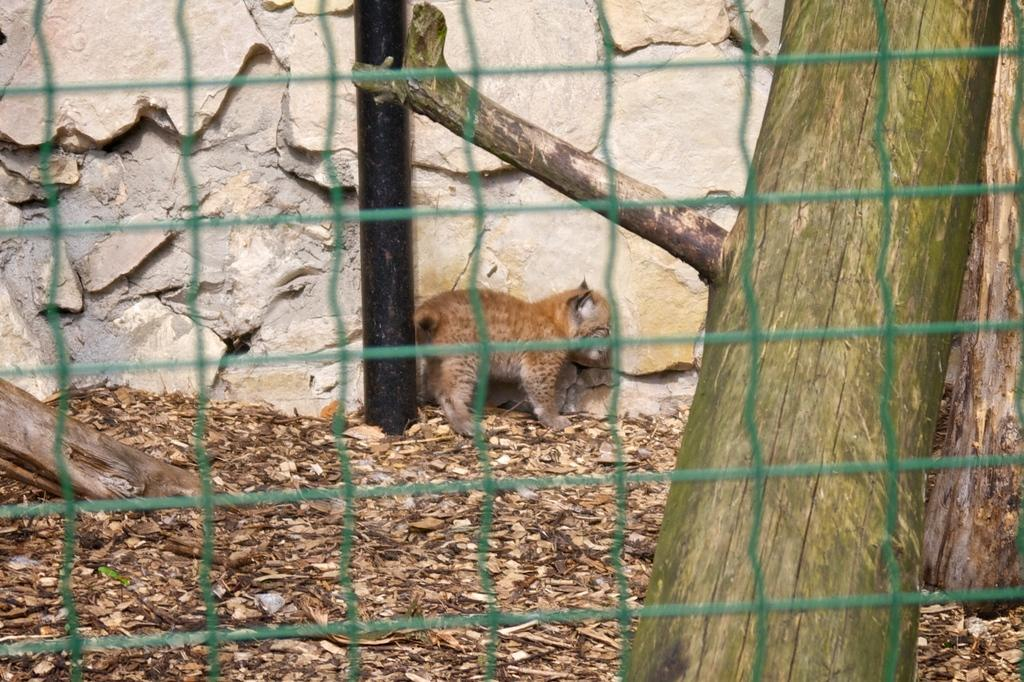What is the primary object in the image? There is a net in the image. What natural element can be seen in the image? A tree branch is visible in the image. What type of surface is present in the image? There is a surface with dried leaves in the image. What man-made structure is present in the image? A rock wall is present in the image. What vertical object is visible in the image? There is a pole in the image. What type of animal is observable in the image? A cub is observable in the image. What type of apparel is the cub wearing in the image? There is no apparel visible on the cub in the image; it is a wild animal. 